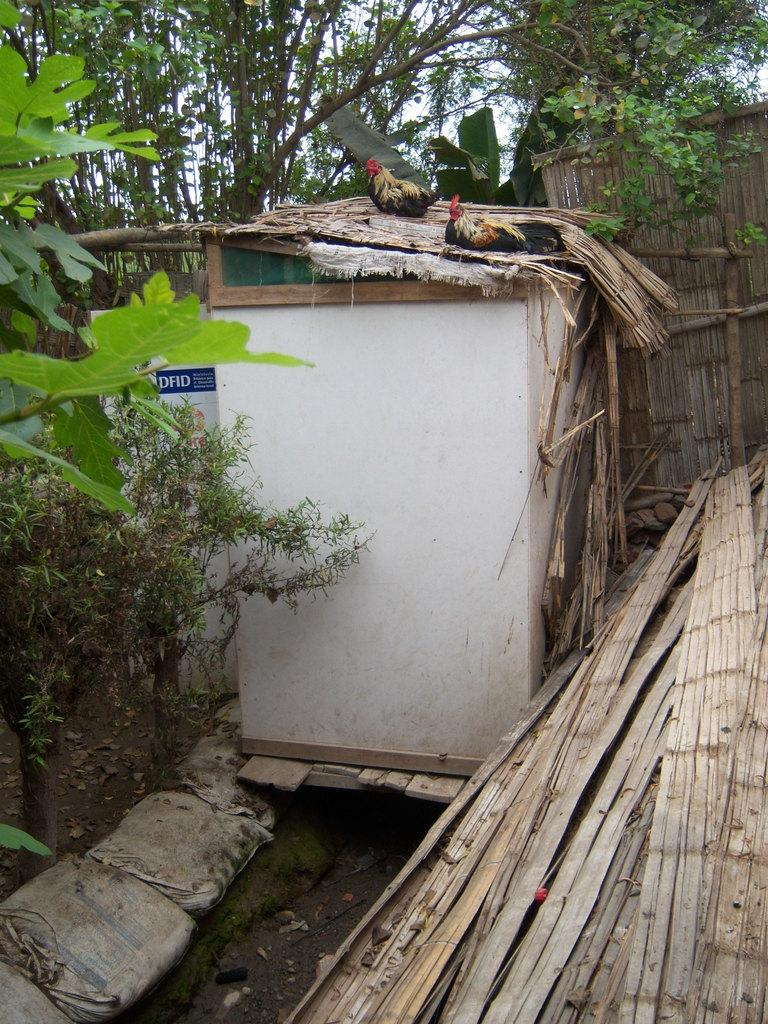What animals are present in the image? There are hens above a cabin in the image. What type of vegetation can be seen in the image? There are plants and trees in the image. What objects are present in the image that might be used for carrying items? There are bags in the image. What type of material is used for the objects in the image? There are wooden objects in the image. What word is being spelled out by the hens in the image? The hens are not spelling out any word in the image; they are simply present above the cabin. Can you see a tramp in the image? There is no tramp present in the image. Is there a pig visible in the image? There is no pig visible in the image. 